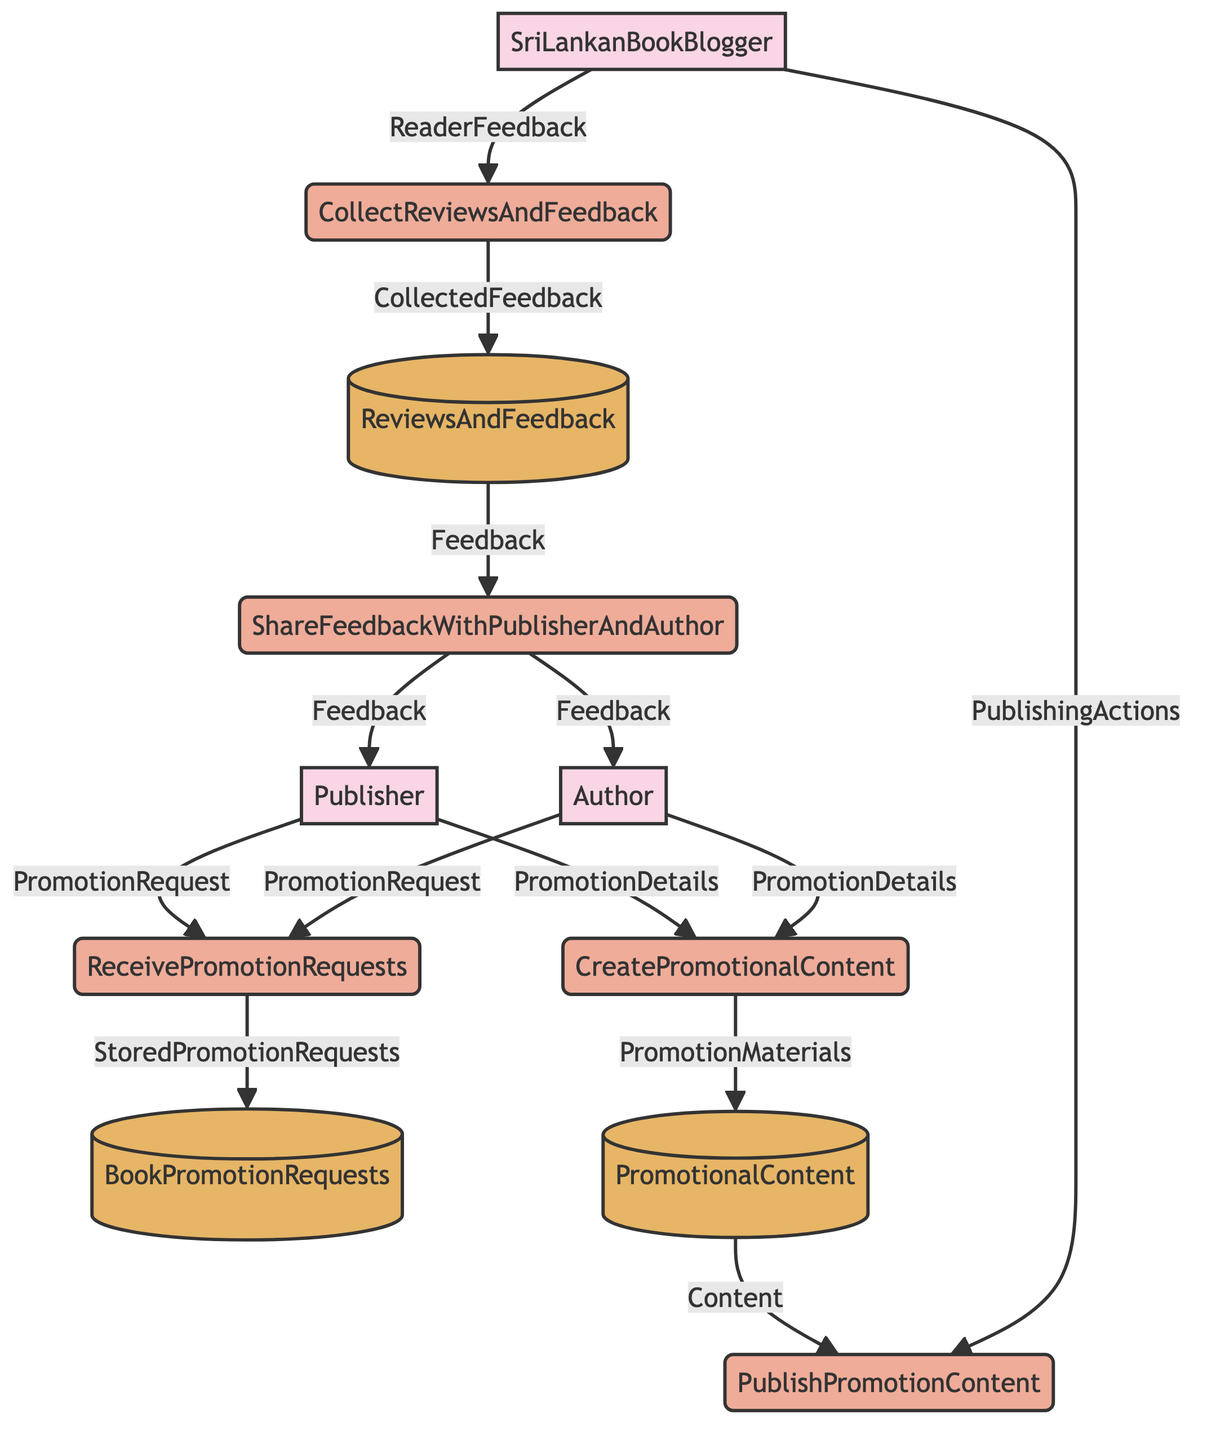What external entities are involved in this diagram? The external entities listed in the diagram are Sri Lankan Book Blogger, Publisher, and Author. These entities represent the individuals or organizations that interact with the processes shown in the diagram.
Answer: Sri Lankan Book Blogger, Publisher, Author How many processes are in the diagram? The diagram contains five processes. By counting the labeled processes (Receive Promotion Requests, Create Promotional Content, Publish Promotion Content, Collect Reviews and Feedback, Share Feedback With Publisher and Author), we can determine the total number.
Answer: Five What is the output of the "Receive Promotion Requests" process? The output from the "Receive Promotion Requests" process is "Stored Promotion Requests." This indicates that the process takes input from publishers and authors and stores their promotion requests for further use.
Answer: Stored Promotion Requests Who provides inputs to the "Create Promotional Content" process? Both the Publisher and Author provide inputs to the "Create Promotional Content" process. This information comes from the directed edges leading into the process, confirming that both external entities contribute to the creation of promotional content together.
Answer: Publisher, Author What data flows from "Promotional Content" to "Publish Promotion Content"? The data that flows from "Promotional Content" to "Publish Promotion Content" is labeled as "Content." This specifies the actual promotional materials being published by the Sri Lankan Book Blogger.
Answer: Content How is feedback shared with the Publisher and Author after collection? Feedback is shared with the Publisher and Author through the "Share Feedback With Publisher and Author" process. Collected feedback is sent output from this process to both the Publisher and Author, ensuring they receive insights from readers.
Answer: Feedback What is the final destination of the "Collect Reviews And Feedback" process? The final destination of the "Collect Reviews And Feedback" process is the "Reviews And Feedback" datastore. This indicates that the feedback gathered from readers is stored in this specific data store for future reference and analysis.
Answer: Reviews And Feedback Which entity is responsible for publishing the promotional content? The entity responsible for publishing the promotional content is the Sri Lankan Book Blogger. According to the diagram, this entity interacts with the "Publish Promotion Content" process to execute the publishing actions.
Answer: Sri Lankan Book Blogger What happens to the collected feedback after the "Collect Reviews And Feedback" process? After the "Collect Reviews And Feedback" process, the collected feedback is directed towards the "Share Feedback With Publisher And Author" process. This step indicates that the feedback is subsequently prepared for sharing with the external entities involved.
Answer: Share Feedback With Publisher And Author 